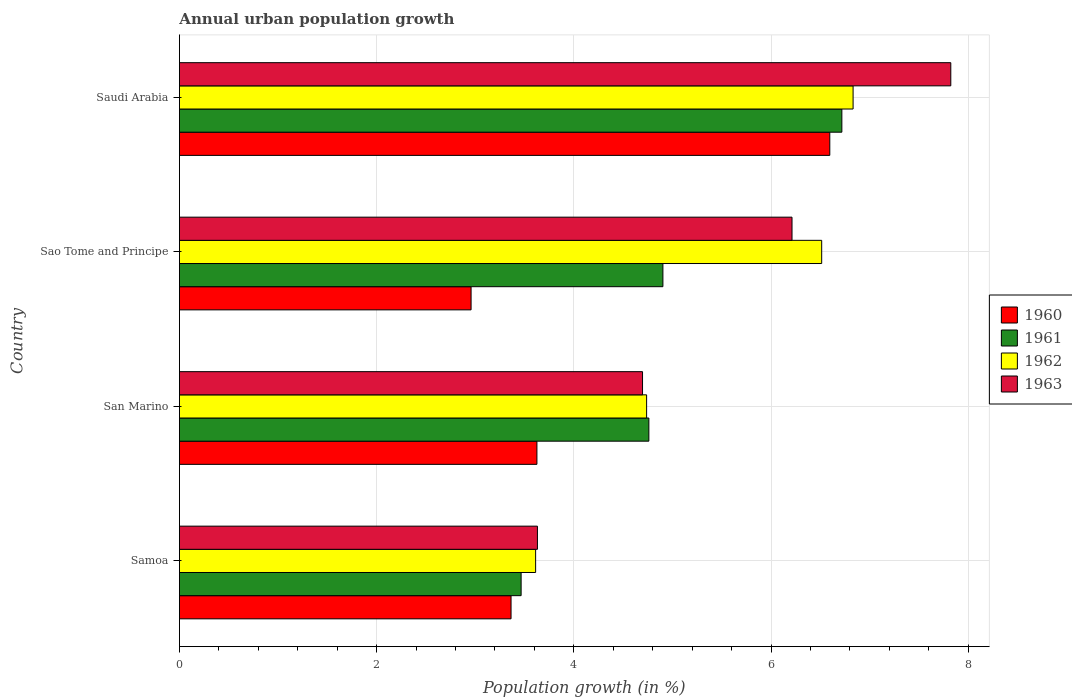How many different coloured bars are there?
Offer a terse response. 4. How many groups of bars are there?
Provide a short and direct response. 4. How many bars are there on the 2nd tick from the bottom?
Make the answer very short. 4. What is the label of the 4th group of bars from the top?
Your answer should be very brief. Samoa. What is the percentage of urban population growth in 1960 in Samoa?
Make the answer very short. 3.36. Across all countries, what is the maximum percentage of urban population growth in 1963?
Keep it short and to the point. 7.82. Across all countries, what is the minimum percentage of urban population growth in 1960?
Make the answer very short. 2.96. In which country was the percentage of urban population growth in 1963 maximum?
Your answer should be compact. Saudi Arabia. In which country was the percentage of urban population growth in 1960 minimum?
Provide a succinct answer. Sao Tome and Principe. What is the total percentage of urban population growth in 1961 in the graph?
Your answer should be compact. 19.85. What is the difference between the percentage of urban population growth in 1963 in Sao Tome and Principe and that in Saudi Arabia?
Offer a terse response. -1.61. What is the difference between the percentage of urban population growth in 1962 in San Marino and the percentage of urban population growth in 1960 in Sao Tome and Principe?
Offer a very short reply. 1.78. What is the average percentage of urban population growth in 1961 per country?
Your answer should be compact. 4.96. What is the difference between the percentage of urban population growth in 1962 and percentage of urban population growth in 1963 in San Marino?
Your response must be concise. 0.04. What is the ratio of the percentage of urban population growth in 1961 in Samoa to that in San Marino?
Your answer should be compact. 0.73. What is the difference between the highest and the second highest percentage of urban population growth in 1963?
Your response must be concise. 1.61. What is the difference between the highest and the lowest percentage of urban population growth in 1960?
Provide a succinct answer. 3.64. In how many countries, is the percentage of urban population growth in 1960 greater than the average percentage of urban population growth in 1960 taken over all countries?
Provide a short and direct response. 1. Is it the case that in every country, the sum of the percentage of urban population growth in 1961 and percentage of urban population growth in 1962 is greater than the sum of percentage of urban population growth in 1960 and percentage of urban population growth in 1963?
Provide a succinct answer. No. What does the 3rd bar from the top in Saudi Arabia represents?
Keep it short and to the point. 1961. Is it the case that in every country, the sum of the percentage of urban population growth in 1963 and percentage of urban population growth in 1962 is greater than the percentage of urban population growth in 1960?
Give a very brief answer. Yes. How many bars are there?
Provide a short and direct response. 16. Are the values on the major ticks of X-axis written in scientific E-notation?
Ensure brevity in your answer.  No. Does the graph contain any zero values?
Provide a short and direct response. No. Does the graph contain grids?
Your answer should be very brief. Yes. Where does the legend appear in the graph?
Make the answer very short. Center right. How many legend labels are there?
Your answer should be very brief. 4. How are the legend labels stacked?
Offer a terse response. Vertical. What is the title of the graph?
Your answer should be compact. Annual urban population growth. Does "1980" appear as one of the legend labels in the graph?
Your response must be concise. No. What is the label or title of the X-axis?
Your response must be concise. Population growth (in %). What is the Population growth (in %) in 1960 in Samoa?
Offer a very short reply. 3.36. What is the Population growth (in %) in 1961 in Samoa?
Your answer should be very brief. 3.47. What is the Population growth (in %) in 1962 in Samoa?
Keep it short and to the point. 3.61. What is the Population growth (in %) in 1963 in Samoa?
Your response must be concise. 3.63. What is the Population growth (in %) in 1960 in San Marino?
Give a very brief answer. 3.63. What is the Population growth (in %) of 1961 in San Marino?
Offer a terse response. 4.76. What is the Population growth (in %) in 1962 in San Marino?
Your answer should be very brief. 4.74. What is the Population growth (in %) of 1963 in San Marino?
Your answer should be very brief. 4.7. What is the Population growth (in %) of 1960 in Sao Tome and Principe?
Provide a succinct answer. 2.96. What is the Population growth (in %) in 1961 in Sao Tome and Principe?
Ensure brevity in your answer.  4.9. What is the Population growth (in %) of 1962 in Sao Tome and Principe?
Offer a terse response. 6.51. What is the Population growth (in %) in 1963 in Sao Tome and Principe?
Your response must be concise. 6.21. What is the Population growth (in %) of 1960 in Saudi Arabia?
Give a very brief answer. 6.6. What is the Population growth (in %) in 1961 in Saudi Arabia?
Give a very brief answer. 6.72. What is the Population growth (in %) of 1962 in Saudi Arabia?
Offer a very short reply. 6.83. What is the Population growth (in %) of 1963 in Saudi Arabia?
Make the answer very short. 7.82. Across all countries, what is the maximum Population growth (in %) of 1960?
Provide a short and direct response. 6.6. Across all countries, what is the maximum Population growth (in %) in 1961?
Your response must be concise. 6.72. Across all countries, what is the maximum Population growth (in %) in 1962?
Provide a short and direct response. 6.83. Across all countries, what is the maximum Population growth (in %) of 1963?
Your answer should be very brief. 7.82. Across all countries, what is the minimum Population growth (in %) of 1960?
Make the answer very short. 2.96. Across all countries, what is the minimum Population growth (in %) in 1961?
Your answer should be compact. 3.47. Across all countries, what is the minimum Population growth (in %) in 1962?
Your answer should be compact. 3.61. Across all countries, what is the minimum Population growth (in %) in 1963?
Provide a short and direct response. 3.63. What is the total Population growth (in %) in 1960 in the graph?
Ensure brevity in your answer.  16.54. What is the total Population growth (in %) in 1961 in the graph?
Give a very brief answer. 19.85. What is the total Population growth (in %) in 1962 in the graph?
Offer a terse response. 21.69. What is the total Population growth (in %) in 1963 in the graph?
Make the answer very short. 22.36. What is the difference between the Population growth (in %) of 1960 in Samoa and that in San Marino?
Your answer should be compact. -0.26. What is the difference between the Population growth (in %) in 1961 in Samoa and that in San Marino?
Provide a short and direct response. -1.3. What is the difference between the Population growth (in %) in 1962 in Samoa and that in San Marino?
Ensure brevity in your answer.  -1.13. What is the difference between the Population growth (in %) of 1963 in Samoa and that in San Marino?
Your response must be concise. -1.07. What is the difference between the Population growth (in %) in 1960 in Samoa and that in Sao Tome and Principe?
Offer a very short reply. 0.41. What is the difference between the Population growth (in %) in 1961 in Samoa and that in Sao Tome and Principe?
Offer a very short reply. -1.44. What is the difference between the Population growth (in %) of 1962 in Samoa and that in Sao Tome and Principe?
Offer a very short reply. -2.9. What is the difference between the Population growth (in %) of 1963 in Samoa and that in Sao Tome and Principe?
Offer a very short reply. -2.58. What is the difference between the Population growth (in %) in 1960 in Samoa and that in Saudi Arabia?
Provide a succinct answer. -3.23. What is the difference between the Population growth (in %) of 1961 in Samoa and that in Saudi Arabia?
Provide a short and direct response. -3.25. What is the difference between the Population growth (in %) in 1962 in Samoa and that in Saudi Arabia?
Offer a very short reply. -3.22. What is the difference between the Population growth (in %) in 1963 in Samoa and that in Saudi Arabia?
Give a very brief answer. -4.19. What is the difference between the Population growth (in %) in 1960 in San Marino and that in Sao Tome and Principe?
Your response must be concise. 0.67. What is the difference between the Population growth (in %) in 1961 in San Marino and that in Sao Tome and Principe?
Provide a succinct answer. -0.14. What is the difference between the Population growth (in %) of 1962 in San Marino and that in Sao Tome and Principe?
Provide a short and direct response. -1.78. What is the difference between the Population growth (in %) of 1963 in San Marino and that in Sao Tome and Principe?
Ensure brevity in your answer.  -1.52. What is the difference between the Population growth (in %) of 1960 in San Marino and that in Saudi Arabia?
Make the answer very short. -2.97. What is the difference between the Population growth (in %) of 1961 in San Marino and that in Saudi Arabia?
Ensure brevity in your answer.  -1.96. What is the difference between the Population growth (in %) of 1962 in San Marino and that in Saudi Arabia?
Offer a very short reply. -2.09. What is the difference between the Population growth (in %) in 1963 in San Marino and that in Saudi Arabia?
Provide a succinct answer. -3.13. What is the difference between the Population growth (in %) of 1960 in Sao Tome and Principe and that in Saudi Arabia?
Your response must be concise. -3.64. What is the difference between the Population growth (in %) of 1961 in Sao Tome and Principe and that in Saudi Arabia?
Provide a succinct answer. -1.81. What is the difference between the Population growth (in %) of 1962 in Sao Tome and Principe and that in Saudi Arabia?
Your answer should be very brief. -0.32. What is the difference between the Population growth (in %) of 1963 in Sao Tome and Principe and that in Saudi Arabia?
Your answer should be compact. -1.61. What is the difference between the Population growth (in %) of 1960 in Samoa and the Population growth (in %) of 1961 in San Marino?
Offer a terse response. -1.4. What is the difference between the Population growth (in %) in 1960 in Samoa and the Population growth (in %) in 1962 in San Marino?
Give a very brief answer. -1.37. What is the difference between the Population growth (in %) of 1960 in Samoa and the Population growth (in %) of 1963 in San Marino?
Ensure brevity in your answer.  -1.33. What is the difference between the Population growth (in %) in 1961 in Samoa and the Population growth (in %) in 1962 in San Marino?
Make the answer very short. -1.27. What is the difference between the Population growth (in %) of 1961 in Samoa and the Population growth (in %) of 1963 in San Marino?
Offer a very short reply. -1.23. What is the difference between the Population growth (in %) of 1962 in Samoa and the Population growth (in %) of 1963 in San Marino?
Give a very brief answer. -1.08. What is the difference between the Population growth (in %) in 1960 in Samoa and the Population growth (in %) in 1961 in Sao Tome and Principe?
Give a very brief answer. -1.54. What is the difference between the Population growth (in %) in 1960 in Samoa and the Population growth (in %) in 1962 in Sao Tome and Principe?
Make the answer very short. -3.15. What is the difference between the Population growth (in %) of 1960 in Samoa and the Population growth (in %) of 1963 in Sao Tome and Principe?
Offer a terse response. -2.85. What is the difference between the Population growth (in %) of 1961 in Samoa and the Population growth (in %) of 1962 in Sao Tome and Principe?
Your answer should be very brief. -3.05. What is the difference between the Population growth (in %) in 1961 in Samoa and the Population growth (in %) in 1963 in Sao Tome and Principe?
Give a very brief answer. -2.75. What is the difference between the Population growth (in %) of 1960 in Samoa and the Population growth (in %) of 1961 in Saudi Arabia?
Your answer should be very brief. -3.35. What is the difference between the Population growth (in %) in 1960 in Samoa and the Population growth (in %) in 1962 in Saudi Arabia?
Offer a very short reply. -3.47. What is the difference between the Population growth (in %) in 1960 in Samoa and the Population growth (in %) in 1963 in Saudi Arabia?
Offer a terse response. -4.46. What is the difference between the Population growth (in %) in 1961 in Samoa and the Population growth (in %) in 1962 in Saudi Arabia?
Ensure brevity in your answer.  -3.37. What is the difference between the Population growth (in %) in 1961 in Samoa and the Population growth (in %) in 1963 in Saudi Arabia?
Offer a terse response. -4.36. What is the difference between the Population growth (in %) in 1962 in Samoa and the Population growth (in %) in 1963 in Saudi Arabia?
Offer a very short reply. -4.21. What is the difference between the Population growth (in %) in 1960 in San Marino and the Population growth (in %) in 1961 in Sao Tome and Principe?
Offer a very short reply. -1.28. What is the difference between the Population growth (in %) in 1960 in San Marino and the Population growth (in %) in 1962 in Sao Tome and Principe?
Your answer should be very brief. -2.89. What is the difference between the Population growth (in %) of 1960 in San Marino and the Population growth (in %) of 1963 in Sao Tome and Principe?
Ensure brevity in your answer.  -2.59. What is the difference between the Population growth (in %) in 1961 in San Marino and the Population growth (in %) in 1962 in Sao Tome and Principe?
Provide a succinct answer. -1.75. What is the difference between the Population growth (in %) of 1961 in San Marino and the Population growth (in %) of 1963 in Sao Tome and Principe?
Provide a short and direct response. -1.45. What is the difference between the Population growth (in %) of 1962 in San Marino and the Population growth (in %) of 1963 in Sao Tome and Principe?
Your answer should be very brief. -1.47. What is the difference between the Population growth (in %) in 1960 in San Marino and the Population growth (in %) in 1961 in Saudi Arabia?
Your answer should be very brief. -3.09. What is the difference between the Population growth (in %) of 1960 in San Marino and the Population growth (in %) of 1962 in Saudi Arabia?
Your answer should be compact. -3.21. What is the difference between the Population growth (in %) of 1960 in San Marino and the Population growth (in %) of 1963 in Saudi Arabia?
Offer a very short reply. -4.2. What is the difference between the Population growth (in %) in 1961 in San Marino and the Population growth (in %) in 1962 in Saudi Arabia?
Your response must be concise. -2.07. What is the difference between the Population growth (in %) in 1961 in San Marino and the Population growth (in %) in 1963 in Saudi Arabia?
Offer a terse response. -3.06. What is the difference between the Population growth (in %) of 1962 in San Marino and the Population growth (in %) of 1963 in Saudi Arabia?
Your response must be concise. -3.08. What is the difference between the Population growth (in %) of 1960 in Sao Tome and Principe and the Population growth (in %) of 1961 in Saudi Arabia?
Your answer should be compact. -3.76. What is the difference between the Population growth (in %) of 1960 in Sao Tome and Principe and the Population growth (in %) of 1962 in Saudi Arabia?
Your answer should be compact. -3.87. What is the difference between the Population growth (in %) in 1960 in Sao Tome and Principe and the Population growth (in %) in 1963 in Saudi Arabia?
Give a very brief answer. -4.86. What is the difference between the Population growth (in %) of 1961 in Sao Tome and Principe and the Population growth (in %) of 1962 in Saudi Arabia?
Make the answer very short. -1.93. What is the difference between the Population growth (in %) of 1961 in Sao Tome and Principe and the Population growth (in %) of 1963 in Saudi Arabia?
Ensure brevity in your answer.  -2.92. What is the difference between the Population growth (in %) of 1962 in Sao Tome and Principe and the Population growth (in %) of 1963 in Saudi Arabia?
Your response must be concise. -1.31. What is the average Population growth (in %) of 1960 per country?
Your answer should be compact. 4.14. What is the average Population growth (in %) of 1961 per country?
Offer a very short reply. 4.96. What is the average Population growth (in %) of 1962 per country?
Keep it short and to the point. 5.42. What is the average Population growth (in %) in 1963 per country?
Provide a short and direct response. 5.59. What is the difference between the Population growth (in %) in 1960 and Population growth (in %) in 1961 in Samoa?
Make the answer very short. -0.1. What is the difference between the Population growth (in %) in 1960 and Population growth (in %) in 1962 in Samoa?
Your response must be concise. -0.25. What is the difference between the Population growth (in %) in 1960 and Population growth (in %) in 1963 in Samoa?
Provide a succinct answer. -0.27. What is the difference between the Population growth (in %) in 1961 and Population growth (in %) in 1962 in Samoa?
Make the answer very short. -0.15. What is the difference between the Population growth (in %) of 1961 and Population growth (in %) of 1963 in Samoa?
Offer a terse response. -0.17. What is the difference between the Population growth (in %) of 1962 and Population growth (in %) of 1963 in Samoa?
Provide a short and direct response. -0.02. What is the difference between the Population growth (in %) of 1960 and Population growth (in %) of 1961 in San Marino?
Provide a succinct answer. -1.14. What is the difference between the Population growth (in %) of 1960 and Population growth (in %) of 1962 in San Marino?
Ensure brevity in your answer.  -1.11. What is the difference between the Population growth (in %) in 1960 and Population growth (in %) in 1963 in San Marino?
Provide a succinct answer. -1.07. What is the difference between the Population growth (in %) of 1961 and Population growth (in %) of 1962 in San Marino?
Your answer should be compact. 0.02. What is the difference between the Population growth (in %) in 1961 and Population growth (in %) in 1963 in San Marino?
Provide a short and direct response. 0.06. What is the difference between the Population growth (in %) of 1962 and Population growth (in %) of 1963 in San Marino?
Your answer should be very brief. 0.04. What is the difference between the Population growth (in %) of 1960 and Population growth (in %) of 1961 in Sao Tome and Principe?
Your answer should be compact. -1.95. What is the difference between the Population growth (in %) of 1960 and Population growth (in %) of 1962 in Sao Tome and Principe?
Give a very brief answer. -3.56. What is the difference between the Population growth (in %) of 1960 and Population growth (in %) of 1963 in Sao Tome and Principe?
Give a very brief answer. -3.25. What is the difference between the Population growth (in %) of 1961 and Population growth (in %) of 1962 in Sao Tome and Principe?
Give a very brief answer. -1.61. What is the difference between the Population growth (in %) in 1961 and Population growth (in %) in 1963 in Sao Tome and Principe?
Offer a terse response. -1.31. What is the difference between the Population growth (in %) in 1962 and Population growth (in %) in 1963 in Sao Tome and Principe?
Provide a succinct answer. 0.3. What is the difference between the Population growth (in %) of 1960 and Population growth (in %) of 1961 in Saudi Arabia?
Make the answer very short. -0.12. What is the difference between the Population growth (in %) in 1960 and Population growth (in %) in 1962 in Saudi Arabia?
Keep it short and to the point. -0.24. What is the difference between the Population growth (in %) in 1960 and Population growth (in %) in 1963 in Saudi Arabia?
Offer a terse response. -1.23. What is the difference between the Population growth (in %) in 1961 and Population growth (in %) in 1962 in Saudi Arabia?
Your answer should be very brief. -0.11. What is the difference between the Population growth (in %) in 1961 and Population growth (in %) in 1963 in Saudi Arabia?
Provide a succinct answer. -1.1. What is the difference between the Population growth (in %) in 1962 and Population growth (in %) in 1963 in Saudi Arabia?
Offer a very short reply. -0.99. What is the ratio of the Population growth (in %) of 1960 in Samoa to that in San Marino?
Offer a terse response. 0.93. What is the ratio of the Population growth (in %) of 1961 in Samoa to that in San Marino?
Your response must be concise. 0.73. What is the ratio of the Population growth (in %) in 1962 in Samoa to that in San Marino?
Ensure brevity in your answer.  0.76. What is the ratio of the Population growth (in %) of 1963 in Samoa to that in San Marino?
Offer a terse response. 0.77. What is the ratio of the Population growth (in %) of 1960 in Samoa to that in Sao Tome and Principe?
Ensure brevity in your answer.  1.14. What is the ratio of the Population growth (in %) of 1961 in Samoa to that in Sao Tome and Principe?
Your answer should be very brief. 0.71. What is the ratio of the Population growth (in %) in 1962 in Samoa to that in Sao Tome and Principe?
Your answer should be compact. 0.55. What is the ratio of the Population growth (in %) of 1963 in Samoa to that in Sao Tome and Principe?
Your response must be concise. 0.58. What is the ratio of the Population growth (in %) in 1960 in Samoa to that in Saudi Arabia?
Keep it short and to the point. 0.51. What is the ratio of the Population growth (in %) of 1961 in Samoa to that in Saudi Arabia?
Offer a terse response. 0.52. What is the ratio of the Population growth (in %) of 1962 in Samoa to that in Saudi Arabia?
Your response must be concise. 0.53. What is the ratio of the Population growth (in %) in 1963 in Samoa to that in Saudi Arabia?
Provide a short and direct response. 0.46. What is the ratio of the Population growth (in %) of 1960 in San Marino to that in Sao Tome and Principe?
Make the answer very short. 1.23. What is the ratio of the Population growth (in %) of 1961 in San Marino to that in Sao Tome and Principe?
Your answer should be compact. 0.97. What is the ratio of the Population growth (in %) of 1962 in San Marino to that in Sao Tome and Principe?
Your response must be concise. 0.73. What is the ratio of the Population growth (in %) of 1963 in San Marino to that in Sao Tome and Principe?
Ensure brevity in your answer.  0.76. What is the ratio of the Population growth (in %) of 1960 in San Marino to that in Saudi Arabia?
Ensure brevity in your answer.  0.55. What is the ratio of the Population growth (in %) in 1961 in San Marino to that in Saudi Arabia?
Provide a succinct answer. 0.71. What is the ratio of the Population growth (in %) in 1962 in San Marino to that in Saudi Arabia?
Provide a succinct answer. 0.69. What is the ratio of the Population growth (in %) in 1963 in San Marino to that in Saudi Arabia?
Your answer should be compact. 0.6. What is the ratio of the Population growth (in %) of 1960 in Sao Tome and Principe to that in Saudi Arabia?
Your response must be concise. 0.45. What is the ratio of the Population growth (in %) in 1961 in Sao Tome and Principe to that in Saudi Arabia?
Your answer should be very brief. 0.73. What is the ratio of the Population growth (in %) of 1962 in Sao Tome and Principe to that in Saudi Arabia?
Your response must be concise. 0.95. What is the ratio of the Population growth (in %) of 1963 in Sao Tome and Principe to that in Saudi Arabia?
Offer a very short reply. 0.79. What is the difference between the highest and the second highest Population growth (in %) in 1960?
Make the answer very short. 2.97. What is the difference between the highest and the second highest Population growth (in %) of 1961?
Make the answer very short. 1.81. What is the difference between the highest and the second highest Population growth (in %) in 1962?
Provide a short and direct response. 0.32. What is the difference between the highest and the second highest Population growth (in %) in 1963?
Provide a succinct answer. 1.61. What is the difference between the highest and the lowest Population growth (in %) of 1960?
Give a very brief answer. 3.64. What is the difference between the highest and the lowest Population growth (in %) in 1961?
Offer a very short reply. 3.25. What is the difference between the highest and the lowest Population growth (in %) in 1962?
Ensure brevity in your answer.  3.22. What is the difference between the highest and the lowest Population growth (in %) of 1963?
Ensure brevity in your answer.  4.19. 